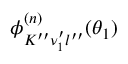Convert formula to latex. <formula><loc_0><loc_0><loc_500><loc_500>\phi _ { K ^ { \prime \prime } \nu _ { 1 } ^ { \prime } l ^ { \prime \prime } } ^ { ( n ) } ( \theta _ { 1 } )</formula> 